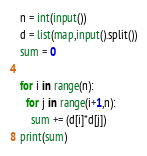Convert code to text. <code><loc_0><loc_0><loc_500><loc_500><_Python_>n = int(input())
d = list(map,input().split())
sum = 0
 
for i in range(n):
  for j in range(i+1,n):
    sum += (d[i]*d[j])
print(sum)</code> 